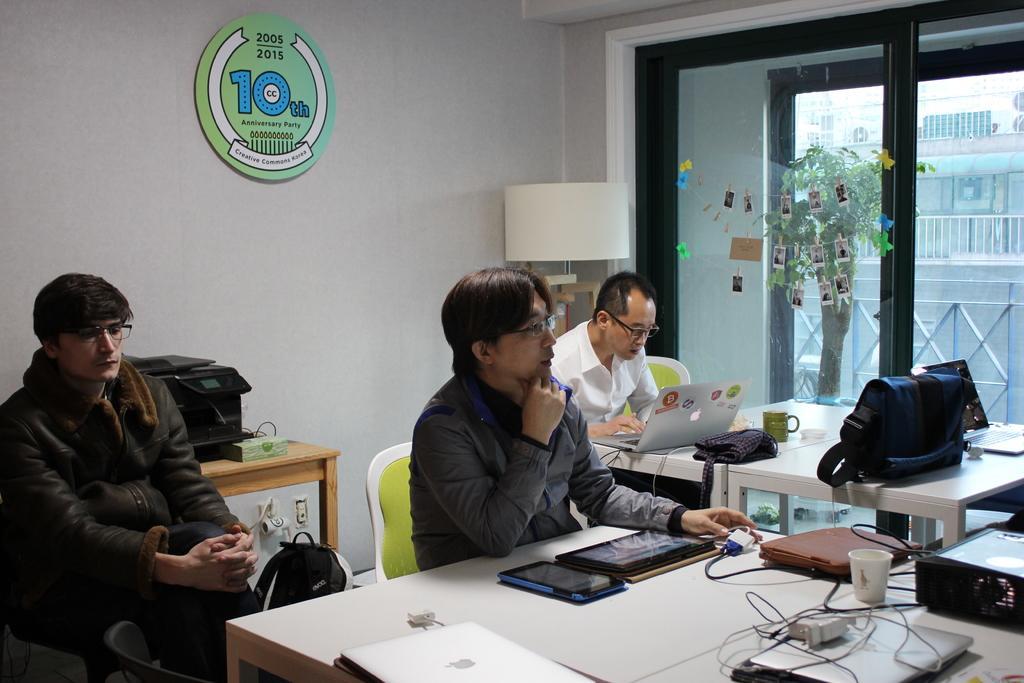How would you summarize this image in a sentence or two? In this image, we can see people sitting on the chairs and are wearing glasses and some of them are wearing coats and there are laptops, tabs, bag, cups, cables and some other objects on the tables. In the background, there is a board on the wall and we can see an object which is in white color and we can see windows and some stickers, through the glass we can see buildings, railings and there is a houseplant. 